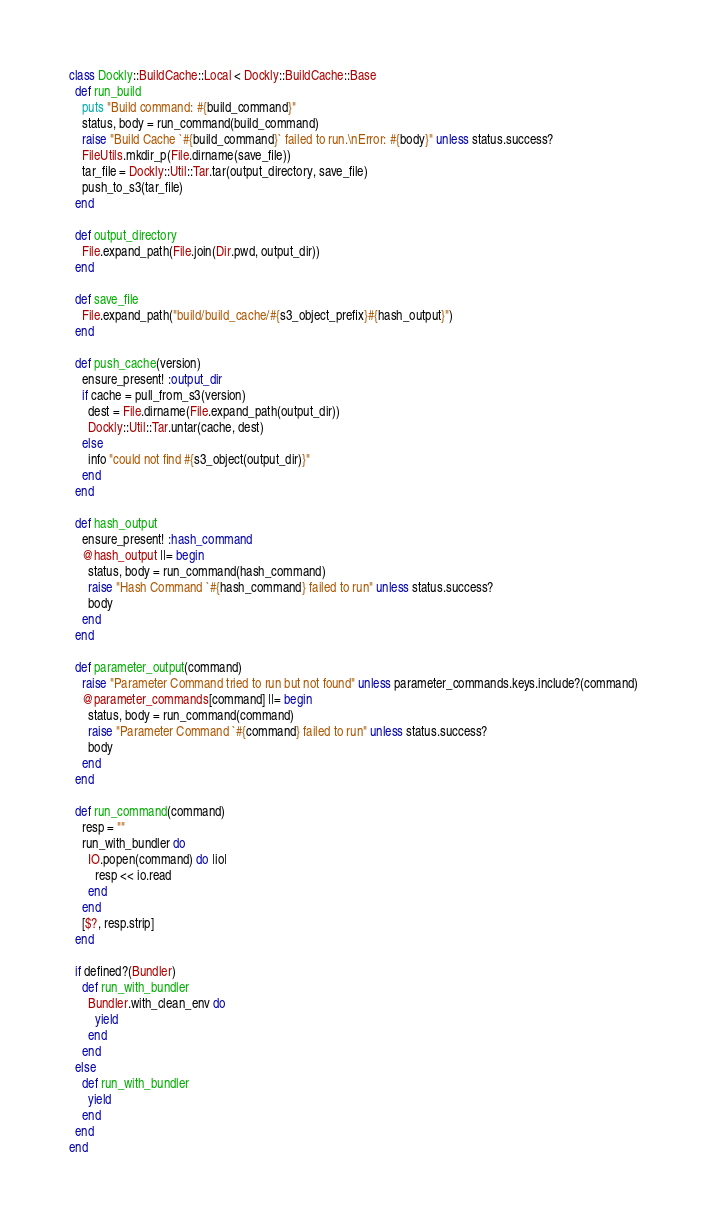Convert code to text. <code><loc_0><loc_0><loc_500><loc_500><_Ruby_>class Dockly::BuildCache::Local < Dockly::BuildCache::Base
  def run_build
    puts "Build command: #{build_command}"
    status, body = run_command(build_command)
    raise "Build Cache `#{build_command}` failed to run.\nError: #{body}" unless status.success?
    FileUtils.mkdir_p(File.dirname(save_file))
    tar_file = Dockly::Util::Tar.tar(output_directory, save_file)
    push_to_s3(tar_file)
  end

  def output_directory
    File.expand_path(File.join(Dir.pwd, output_dir))
  end

  def save_file
    File.expand_path("build/build_cache/#{s3_object_prefix}#{hash_output}")
  end

  def push_cache(version)
    ensure_present! :output_dir
    if cache = pull_from_s3(version)
      dest = File.dirname(File.expand_path(output_dir))
      Dockly::Util::Tar.untar(cache, dest)
    else
      info "could not find #{s3_object(output_dir)}"
    end
  end

  def hash_output
    ensure_present! :hash_command
    @hash_output ||= begin
      status, body = run_command(hash_command)
      raise "Hash Command `#{hash_command} failed to run" unless status.success?
      body
    end
  end

  def parameter_output(command)
    raise "Parameter Command tried to run but not found" unless parameter_commands.keys.include?(command)
    @parameter_commands[command] ||= begin
      status, body = run_command(command)
      raise "Parameter Command `#{command} failed to run" unless status.success?
      body
    end
  end

  def run_command(command)
    resp = ""
    run_with_bundler do
      IO.popen(command) do |io|
        resp << io.read
      end
    end
    [$?, resp.strip]
  end

  if defined?(Bundler)
    def run_with_bundler
      Bundler.with_clean_env do
        yield
      end
    end
  else
    def run_with_bundler
      yield
    end
  end
end
</code> 